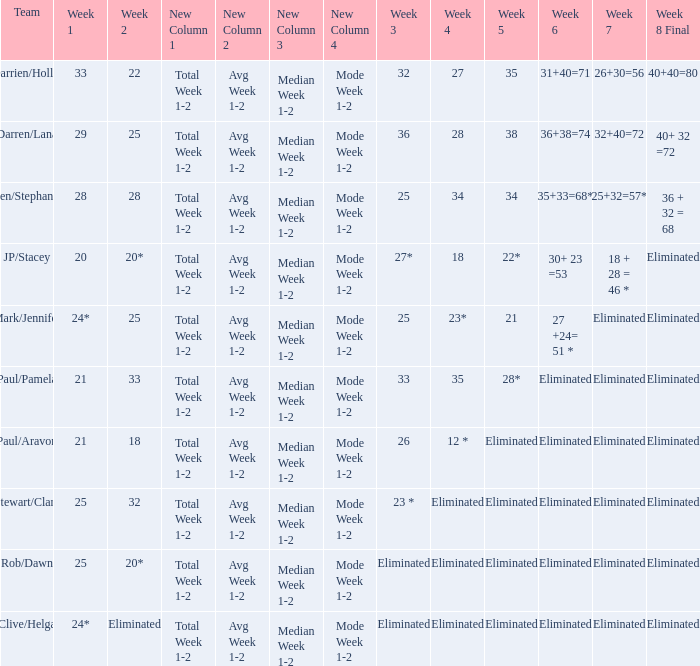Name the team for week 1 of 28 Ben/Stephanie. 